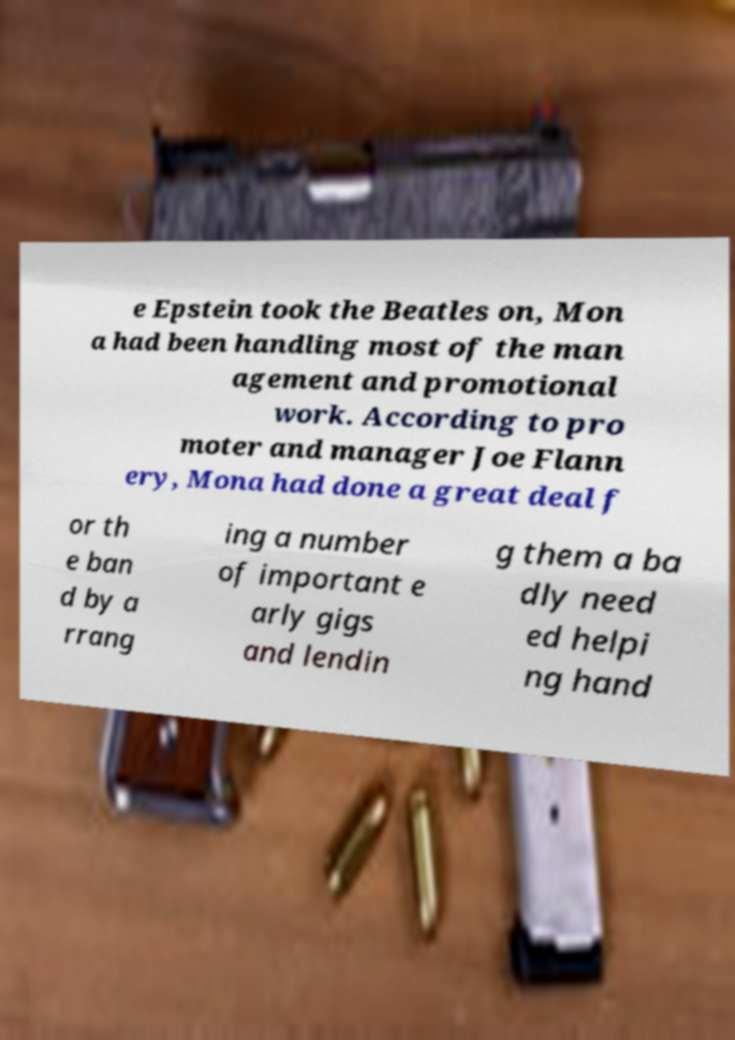Please read and relay the text visible in this image. What does it say? e Epstein took the Beatles on, Mon a had been handling most of the man agement and promotional work. According to pro moter and manager Joe Flann ery, Mona had done a great deal f or th e ban d by a rrang ing a number of important e arly gigs and lendin g them a ba dly need ed helpi ng hand 